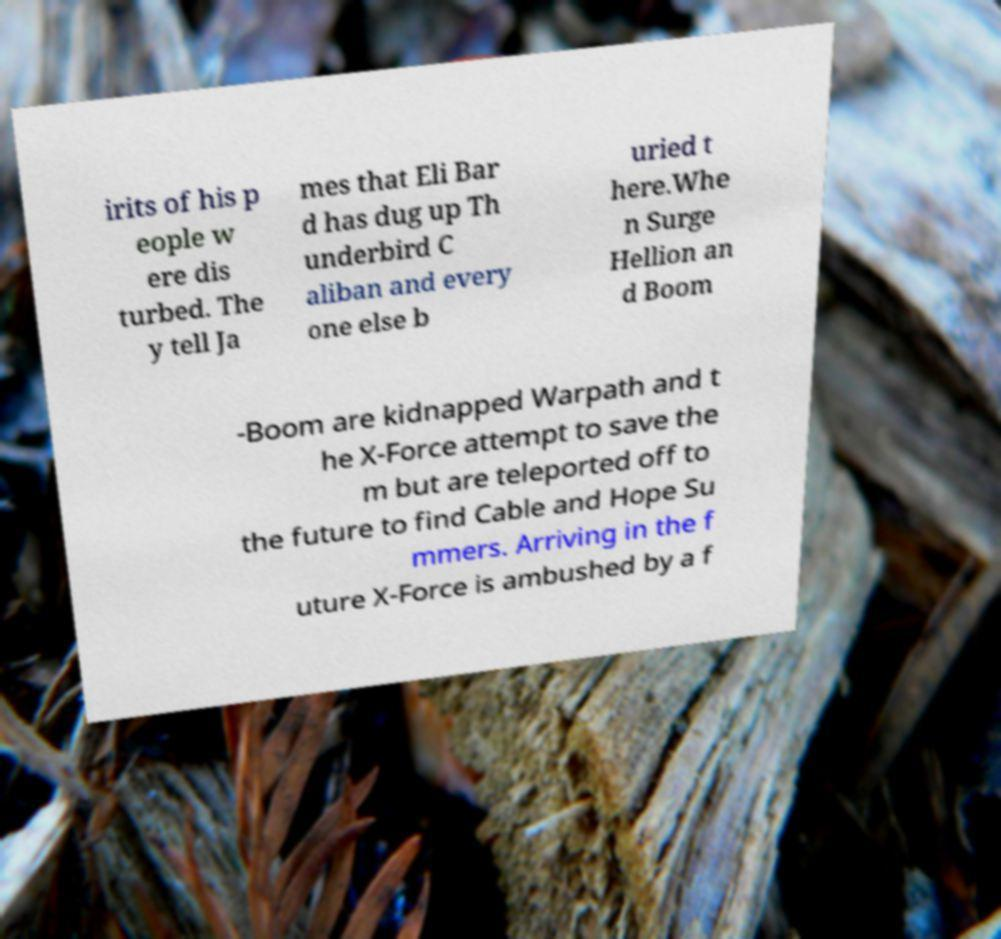What messages or text are displayed in this image? I need them in a readable, typed format. irits of his p eople w ere dis turbed. The y tell Ja mes that Eli Bar d has dug up Th underbird C aliban and every one else b uried t here.Whe n Surge Hellion an d Boom -Boom are kidnapped Warpath and t he X-Force attempt to save the m but are teleported off to the future to find Cable and Hope Su mmers. Arriving in the f uture X-Force is ambushed by a f 